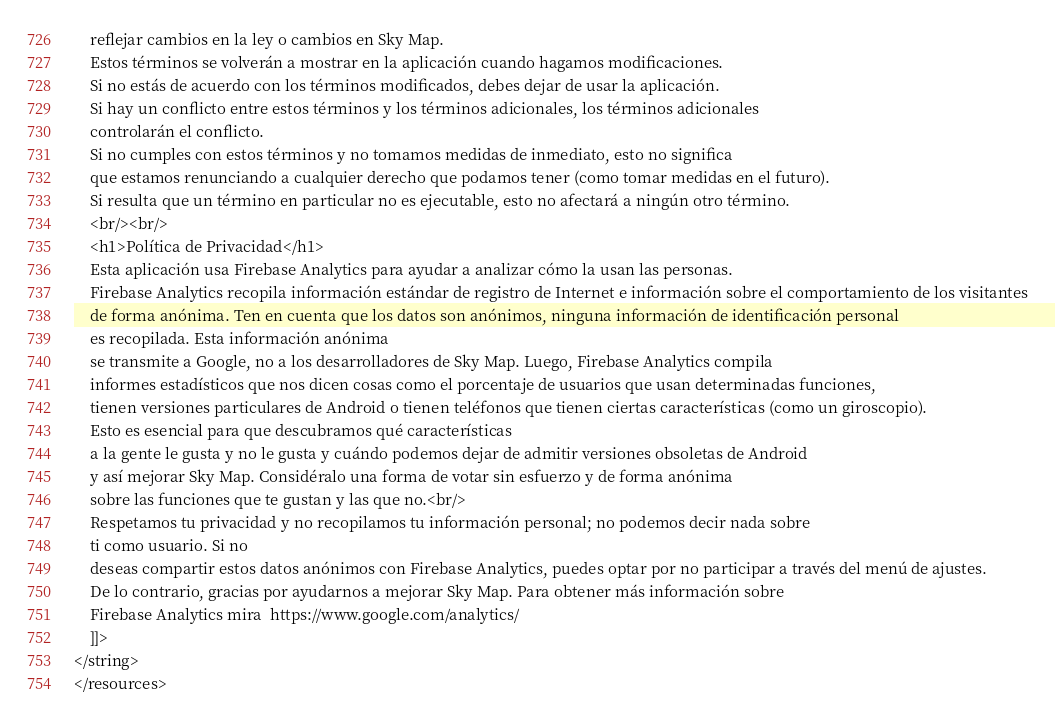Convert code to text. <code><loc_0><loc_0><loc_500><loc_500><_XML_>    reflejar cambios en la ley o cambios en Sky Map.
    Estos términos se volverán a mostrar en la aplicación cuando hagamos modificaciones.
    Si no estás de acuerdo con los términos modificados, debes dejar de usar la aplicación.
    Si hay un conflicto entre estos términos y los términos adicionales, los términos adicionales
    controlarán el conflicto.
    Si no cumples con estos términos y no tomamos medidas de inmediato, esto no significa
    que estamos renunciando a cualquier derecho que podamos tener (como tomar medidas en el futuro).
    Si resulta que un término en particular no es ejecutable, esto no afectará a ningún otro término.
    <br/><br/>
    <h1>Política de Privacidad</h1>
    Esta aplicación usa Firebase Analytics para ayudar a analizar cómo la usan las personas.
    Firebase Analytics recopila información estándar de registro de Internet e información sobre el comportamiento de los visitantes
    de forma anónima. Ten en cuenta que los datos son anónimos, ninguna información de identificación personal
    es recopilada. Esta información anónima
    se transmite a Google, no a los desarrolladores de Sky Map. Luego, Firebase Analytics compila
    informes estadísticos que nos dicen cosas como el porcentaje de usuarios que usan determinadas funciones,
    tienen versiones particulares de Android o tienen teléfonos que tienen ciertas características (como un giroscopio).
    Esto es esencial para que descubramos qué características
    a la gente le gusta y no le gusta y cuándo podemos dejar de admitir versiones obsoletas de Android
    y así mejorar Sky Map. Considéralo una forma de votar sin esfuerzo y de forma anónima
    sobre las funciones que te gustan y las que no.<br/>
    Respetamos tu privacidad y no recopilamos tu información personal; no podemos decir nada sobre
    ti como usuario. Si no
    deseas compartir estos datos anónimos con Firebase Analytics, puedes optar por no participar a través del menú de ajustes.
    De lo contrario, gracias por ayudarnos a mejorar Sky Map. Para obtener más información sobre
    Firebase Analytics mira  https://www.google.com/analytics/
    ]]>
</string>
</resources>
</code> 